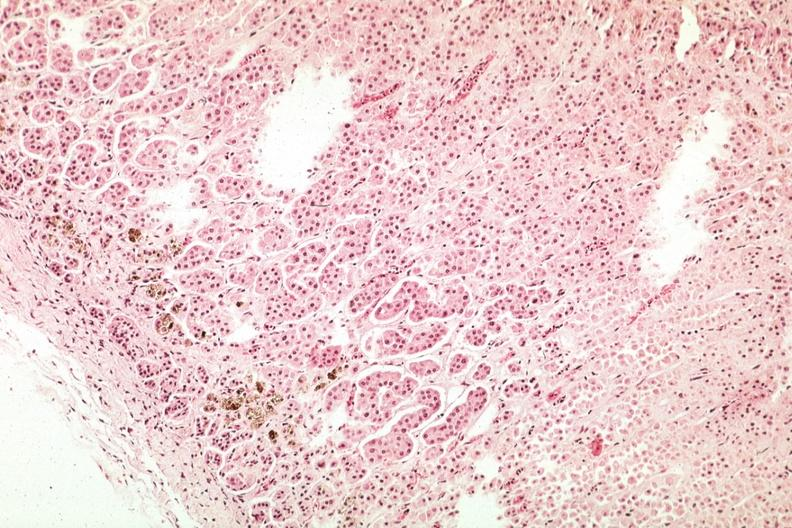what is present?
Answer the question using a single word or phrase. Hemochromatosis 